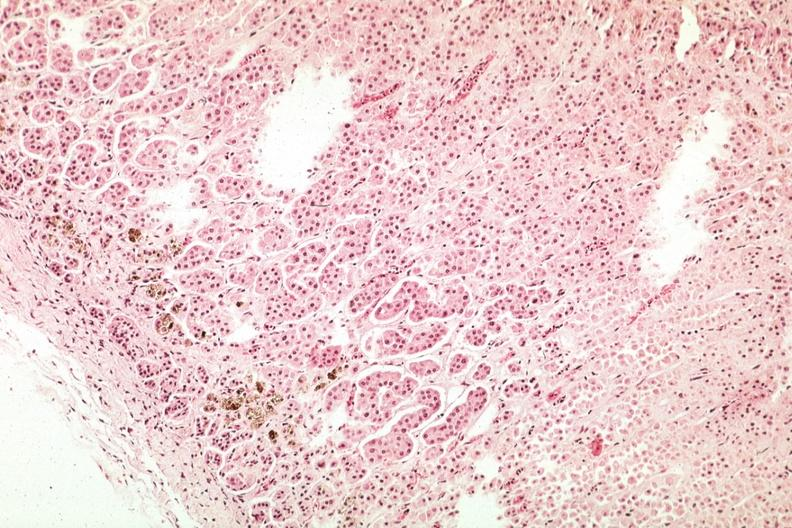what is present?
Answer the question using a single word or phrase. Hemochromatosis 